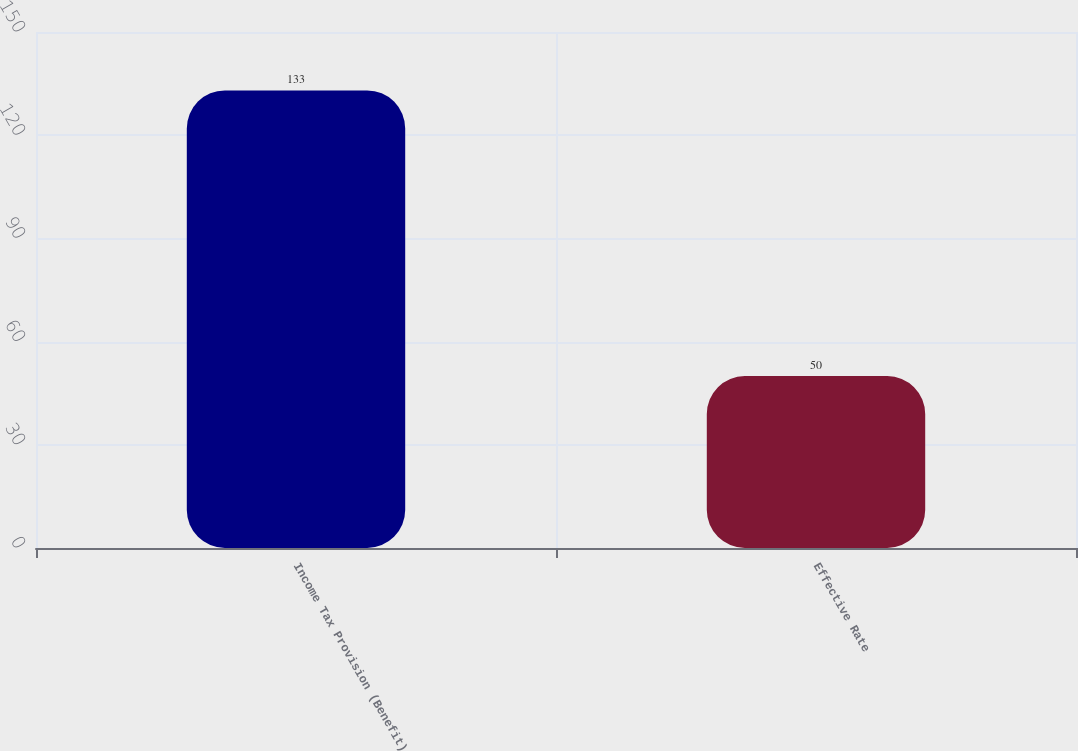<chart> <loc_0><loc_0><loc_500><loc_500><bar_chart><fcel>Income Tax Provision (Benefit)<fcel>Effective Rate<nl><fcel>133<fcel>50<nl></chart> 